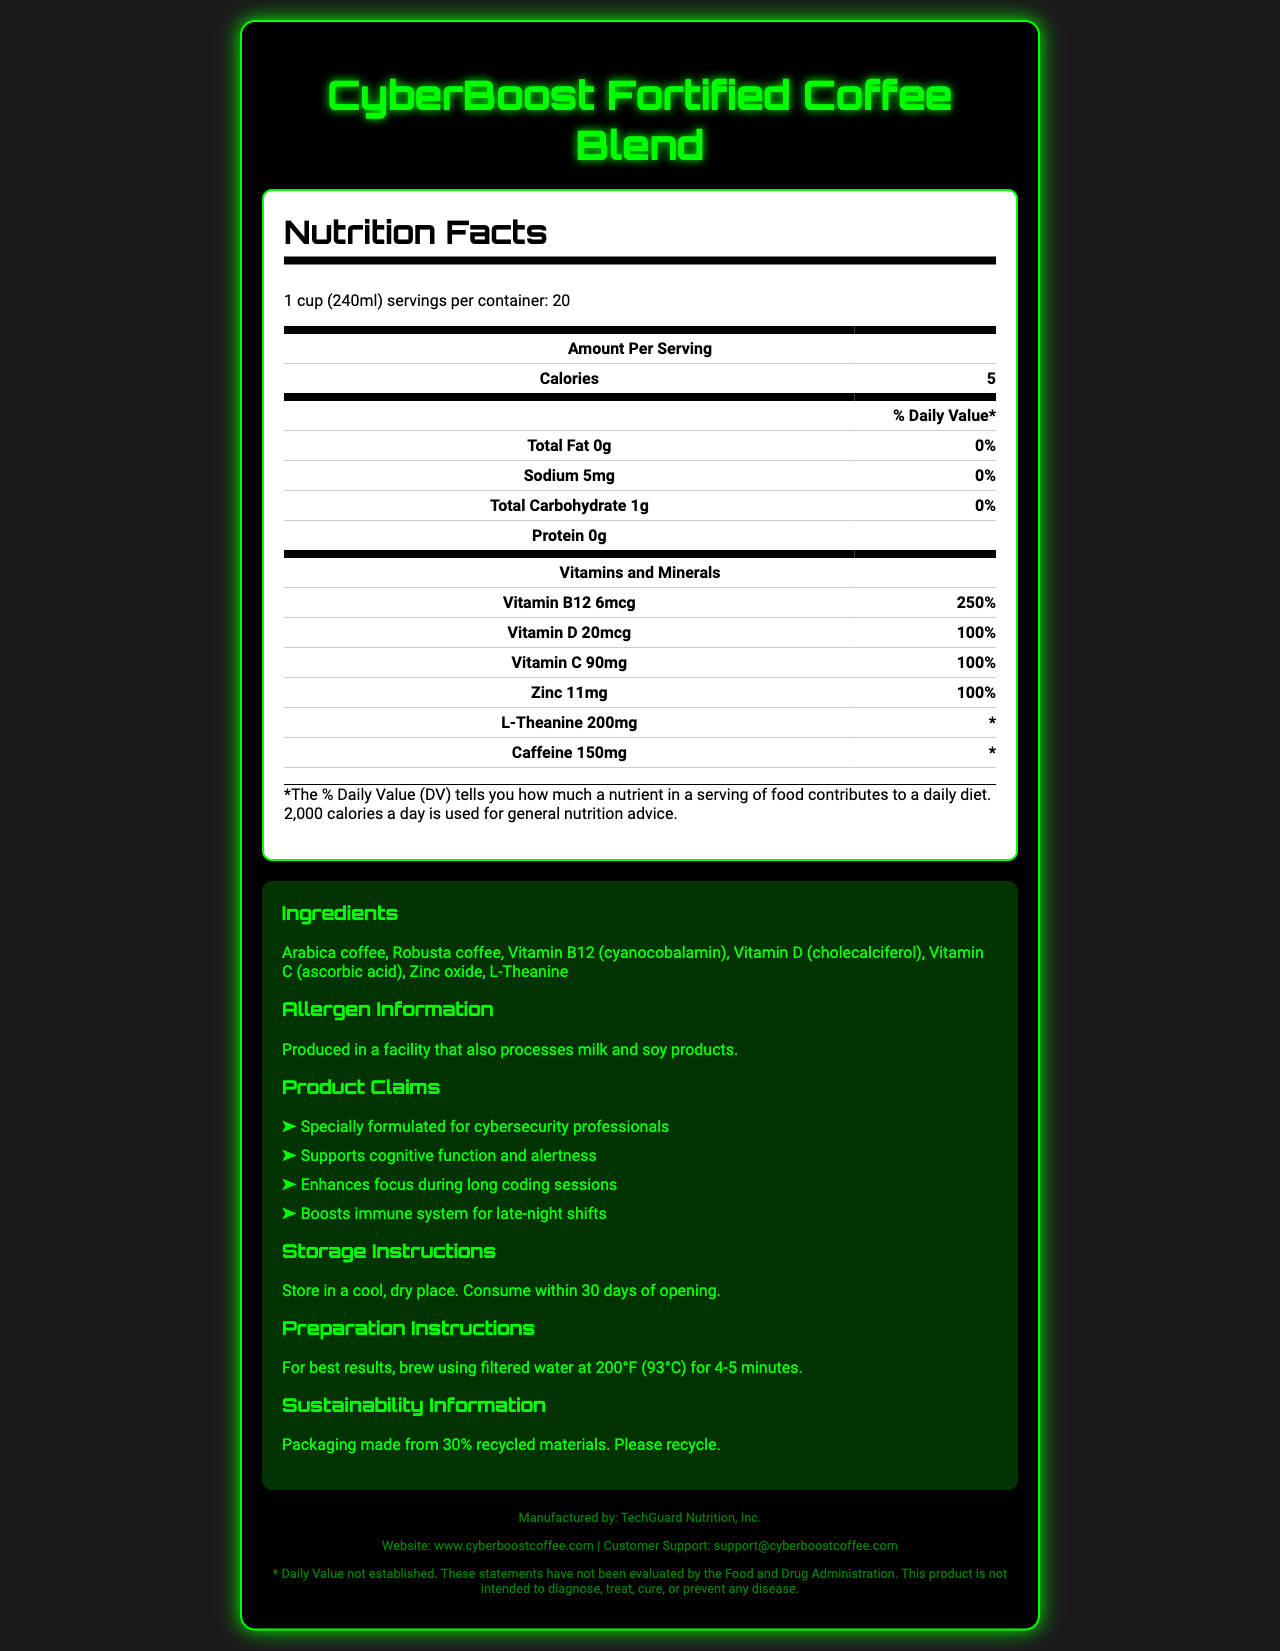what is the serving size of CyberBoost Fortified Coffee Blend? The serving size is clearly stated at the beginning of the Nutrition Facts section.
Answer: 1 cup (240ml) how many servings are there per container? This information is listed right after the serving size in the document.
Answer: 20 how many calories are in one serving? The number of calories per serving is explicitly mentioned in the Nutrition Facts section.
Answer: 5 what is the amount of caffeine per serving? This info can be found under the Vitamins and Minerals section of the document.
Answer: 150mg which vitamin has the highest daily value percentage in CyberBoost Fortified Coffee Blend? Vitamin B12 has a daily value percentage of 250%, the highest among the listed vitamins and minerals.
Answer: Vitamin B12 how much total fat does one serving of this coffee blend contain? The total fat content per serving is mentioned in the Nutrition Facts section and is listed as 0g.
Answer: 0g which ingredient is not listed in the product? A. Arabica coffee B. Vitamin A C. Zinc oxide D. L-Theanine Vitamin A is not listed among the ingredients, while the other options are.
Answer: B. Vitamin A what is the primary purpose claimed for CyberBoost Fortified Coffee Blend? I. Supports cognitive function II. Promotes heart health III. Supports weight loss IV. Reduces stress The first product claim in the list specifically states that CyberBoost Fortified Coffee Blend "Supports cognitive function and alertness."
Answer: I. Supports cognitive function is the product suitable for people with milk allergies? Although the product itself does not contain milk, it is produced in a facility that also processes milk products, suggesting potential cross-contamination.
Answer: No describe the entire document The document is comprehensive and offers all necessary details about the product’s nutritional profile, intended benefits, composition, and usage instructions.
Answer: The document provides detailed information on the nutrition facts, ingredients, allergen information, product claims, storage, preparation, and sustainability instructions for CyberBoost Fortified Coffee Blend. It is designed specifically for cybersecurity professionals and includes specific vitamins and minerals such as Vitamin B12, Vitamin D, Vitamin C, and L-Theanine. The document also mentions the product's packaging and contact information for customer support. what is the total amount of protein per container? The document only provides the amount of protein per serving (0g) and does not give enough information to calculate the total for the entire container.
Answer: Cannot be determined how long should you brew the coffee for best results? The preparation instructions specify that the coffee should be brewed for 4-5 minutes using filtered water at 200°F (93°C).
Answer: 4-5 minutes where should you store the coffee after opening? The storage instructions recommend storing the coffee in a cool, dry place.
Answer: In a cool, dry place which vitamin is listed with a daily value of 100%? A. Vitamin B12 B. Vitamin D C. Zinc D. Vitamin C E. All of the above Both Vitamin D, Vitamin C, and Zinc have a daily value of 100%, making option E the correct one.
Answer: E. All of the above what sustainability information is provided about the packaging? This line is found in the section labeled "Sustainability Information."
Answer: Packaging made from 30% recycled materials. Please recycle. what kind of water is recommended for brewing? The preparation instructions mention that filtered water should be used for brewing the coffee.
Answer: Filtered water 